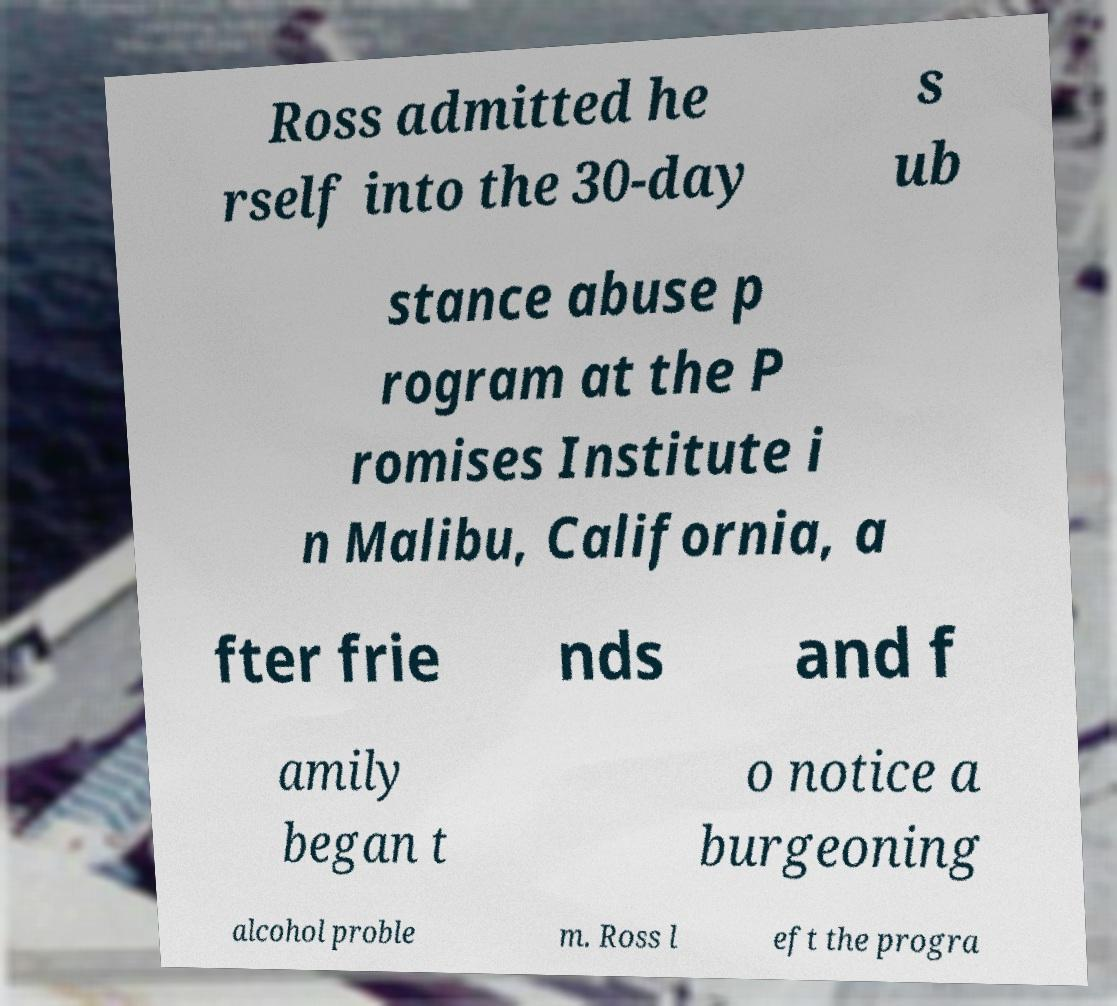Could you extract and type out the text from this image? Ross admitted he rself into the 30-day s ub stance abuse p rogram at the P romises Institute i n Malibu, California, a fter frie nds and f amily began t o notice a burgeoning alcohol proble m. Ross l eft the progra 